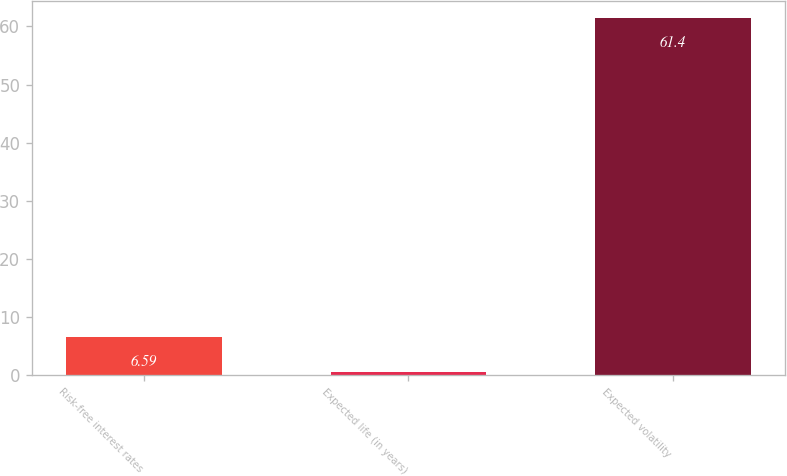Convert chart to OTSL. <chart><loc_0><loc_0><loc_500><loc_500><bar_chart><fcel>Risk-free interest rates<fcel>Expected life (in years)<fcel>Expected volatility<nl><fcel>6.59<fcel>0.5<fcel>61.4<nl></chart> 